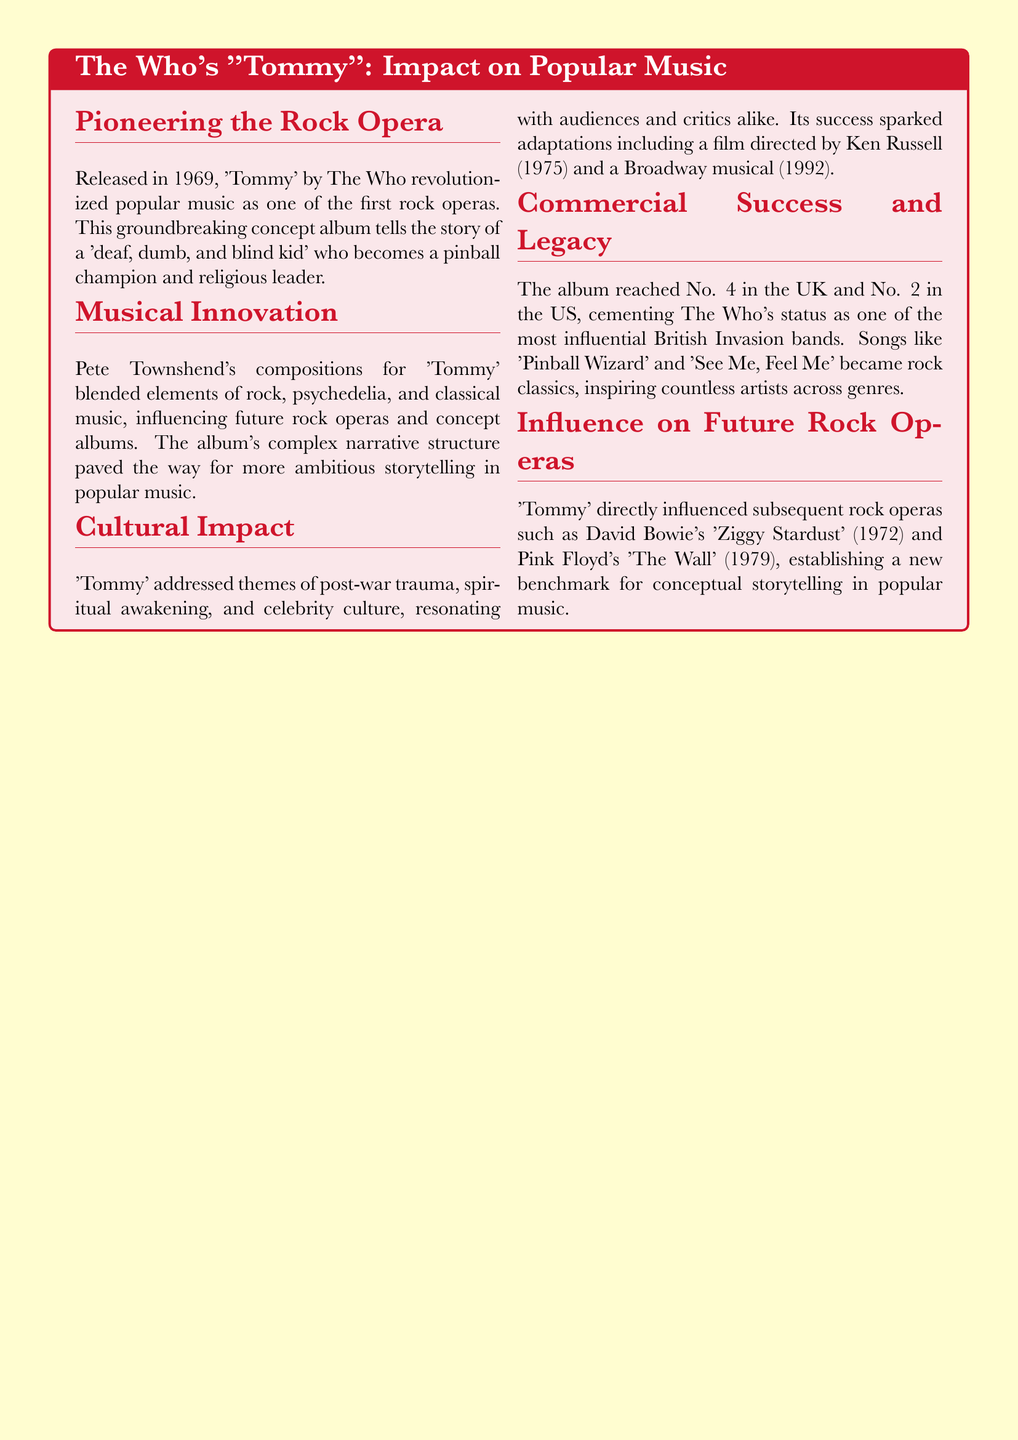What year was "Tommy" released? The year "Tommy" was released is specifically mentioned in the document as 1969.
Answer: 1969 Who composed the music for "Tommy"? The document mentions that Pete Townshend is responsible for the compositions in "Tommy."
Answer: Pete Townshend What is the narrative of "Tommy" mainly about? The content describes the story as centered around a "deaf, dumb, and blind kid" who becomes a pinball champion and religious leader.
Answer: A "deaf, dumb, and blind kid" What themes does "Tommy" address? The document explicitly lists post-war trauma, spiritual awakening, and celebrity culture as themes addressed in "Tommy."
Answer: Post-war trauma, spiritual awakening, and celebrity culture Which film was inspired by "Tommy"? The document refers to a film directed by Ken Russell that was inspired by "Tommy," indicating that adaptations were made following the album's success.
Answer: A film directed by Ken Russell What is the chart position of "Tommy" in the UK? The document states that the album reached No. 4 in the UK.
Answer: No. 4 Which song from "Tommy" became a rock classic? The document mentions "Pinball Wizard" and "See Me, Feel Me" as songs from "Tommy" that became rock classics.
Answer: "Pinball Wizard" What rock opera is directly influenced by "Tommy"? The document lists David Bowie's "Ziggy Stardust" as one rock opera that was directly influenced by "Tommy."
Answer: David Bowie's "Ziggy Stardust" What type of album is "Tommy"? The document categorizes "Tommy" as one of the first rock operas, indicating its innovative nature in popular music.
Answer: Rock opera 